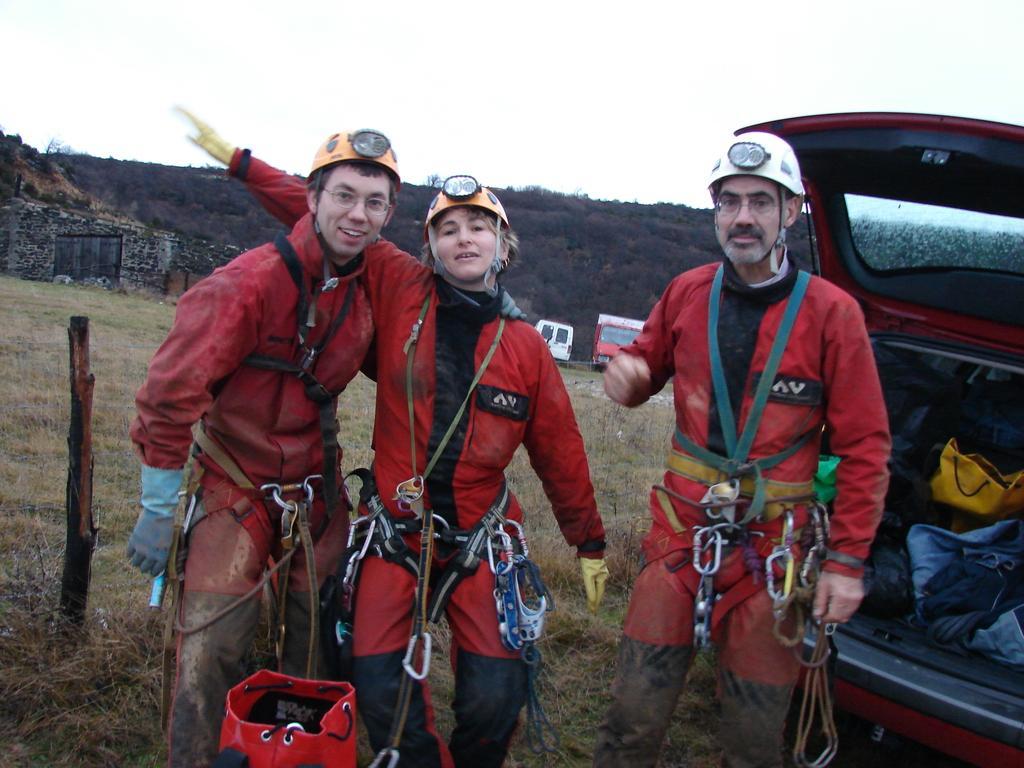Can you describe this image briefly? In this image in the front there are persons standing and in the front there is an object which is red in colour. On the right side there is a car. In the background there are trees and there are vehicles and there's grass on the ground. 